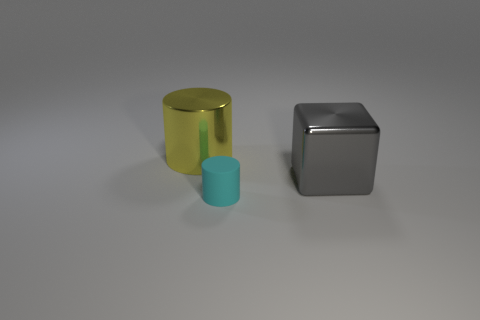Add 2 rubber cylinders. How many objects exist? 5 Subtract all cylinders. How many objects are left? 1 Add 1 large shiny objects. How many large shiny objects are left? 3 Add 1 cyan cylinders. How many cyan cylinders exist? 2 Subtract 1 cyan cylinders. How many objects are left? 2 Subtract all blocks. Subtract all gray metal objects. How many objects are left? 1 